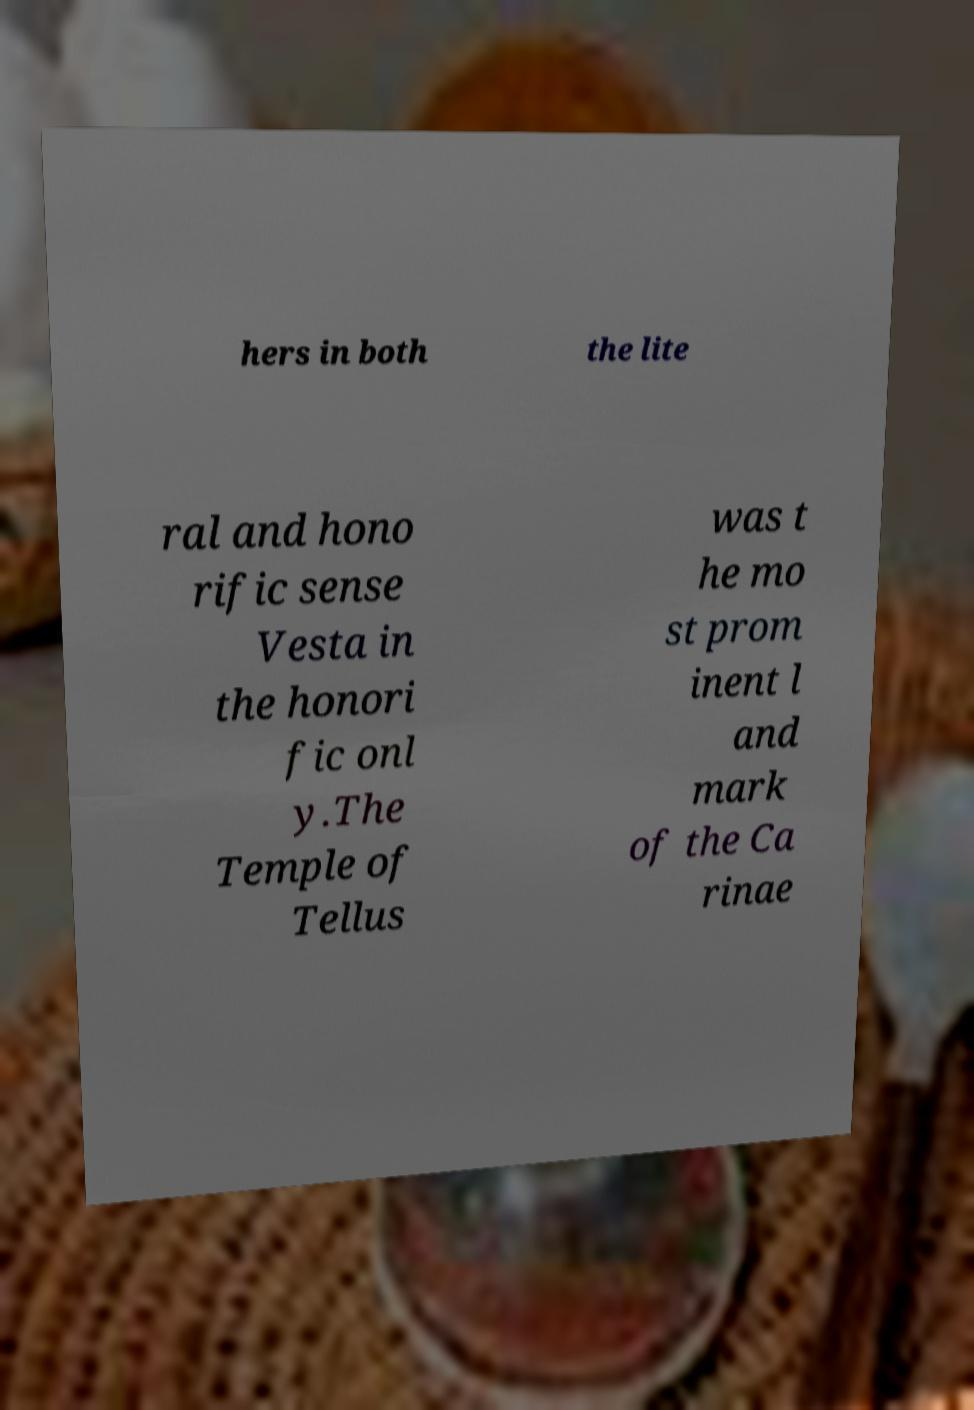Can you read and provide the text displayed in the image?This photo seems to have some interesting text. Can you extract and type it out for me? hers in both the lite ral and hono rific sense Vesta in the honori fic onl y.The Temple of Tellus was t he mo st prom inent l and mark of the Ca rinae 